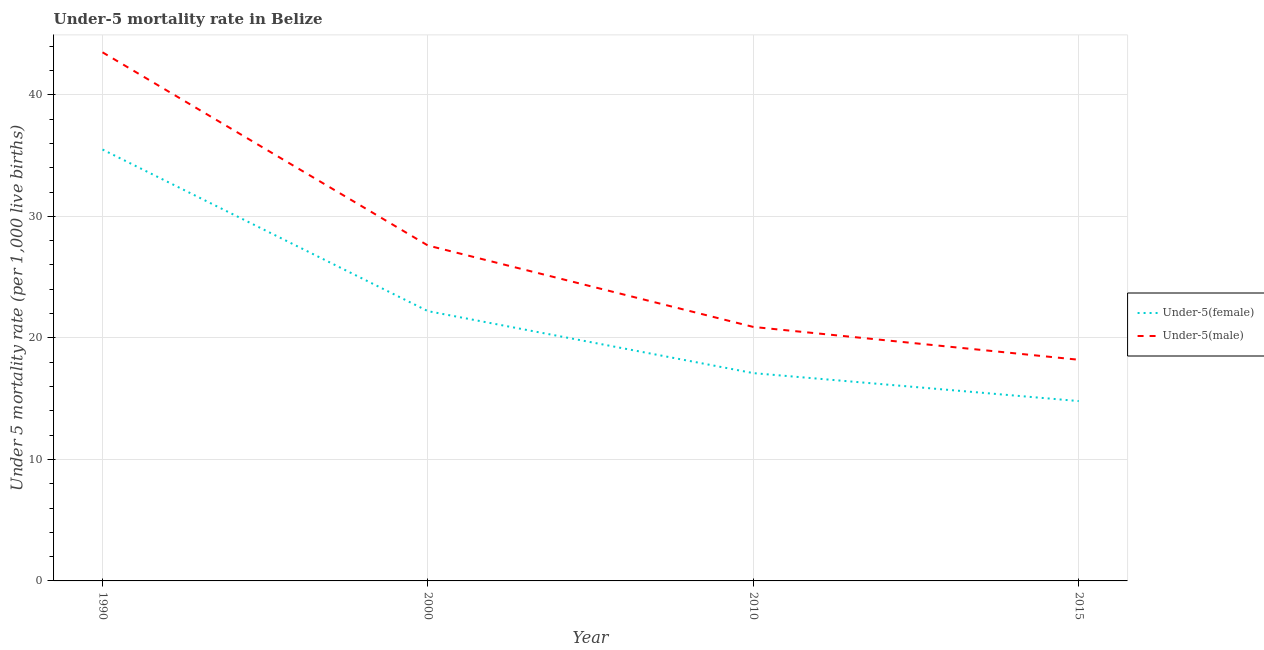How many different coloured lines are there?
Make the answer very short. 2. Does the line corresponding to under-5 female mortality rate intersect with the line corresponding to under-5 male mortality rate?
Offer a very short reply. No. What is the under-5 male mortality rate in 2000?
Make the answer very short. 27.6. Across all years, what is the maximum under-5 male mortality rate?
Give a very brief answer. 43.5. Across all years, what is the minimum under-5 male mortality rate?
Ensure brevity in your answer.  18.2. In which year was the under-5 female mortality rate maximum?
Offer a very short reply. 1990. In which year was the under-5 female mortality rate minimum?
Keep it short and to the point. 2015. What is the total under-5 male mortality rate in the graph?
Your response must be concise. 110.2. What is the difference between the under-5 male mortality rate in 1990 and that in 2010?
Provide a succinct answer. 22.6. What is the difference between the under-5 male mortality rate in 2015 and the under-5 female mortality rate in 2000?
Ensure brevity in your answer.  -4. What is the average under-5 female mortality rate per year?
Make the answer very short. 22.4. In the year 2000, what is the difference between the under-5 male mortality rate and under-5 female mortality rate?
Provide a succinct answer. 5.4. In how many years, is the under-5 female mortality rate greater than 34?
Your response must be concise. 1. What is the ratio of the under-5 male mortality rate in 2000 to that in 2010?
Your answer should be compact. 1.32. What is the difference between the highest and the second highest under-5 female mortality rate?
Provide a short and direct response. 13.3. What is the difference between the highest and the lowest under-5 male mortality rate?
Offer a terse response. 25.3. In how many years, is the under-5 female mortality rate greater than the average under-5 female mortality rate taken over all years?
Make the answer very short. 1. Does the under-5 female mortality rate monotonically increase over the years?
Offer a terse response. No. Is the under-5 male mortality rate strictly less than the under-5 female mortality rate over the years?
Provide a succinct answer. No. How many years are there in the graph?
Provide a succinct answer. 4. What is the difference between two consecutive major ticks on the Y-axis?
Offer a terse response. 10. Are the values on the major ticks of Y-axis written in scientific E-notation?
Keep it short and to the point. No. Does the graph contain any zero values?
Ensure brevity in your answer.  No. How many legend labels are there?
Keep it short and to the point. 2. How are the legend labels stacked?
Your answer should be compact. Vertical. What is the title of the graph?
Offer a very short reply. Under-5 mortality rate in Belize. What is the label or title of the X-axis?
Keep it short and to the point. Year. What is the label or title of the Y-axis?
Provide a short and direct response. Under 5 mortality rate (per 1,0 live births). What is the Under 5 mortality rate (per 1,000 live births) in Under-5(female) in 1990?
Make the answer very short. 35.5. What is the Under 5 mortality rate (per 1,000 live births) of Under-5(male) in 1990?
Make the answer very short. 43.5. What is the Under 5 mortality rate (per 1,000 live births) of Under-5(male) in 2000?
Provide a succinct answer. 27.6. What is the Under 5 mortality rate (per 1,000 live births) of Under-5(male) in 2010?
Make the answer very short. 20.9. What is the Under 5 mortality rate (per 1,000 live births) of Under-5(female) in 2015?
Your answer should be compact. 14.8. What is the Under 5 mortality rate (per 1,000 live births) in Under-5(male) in 2015?
Provide a short and direct response. 18.2. Across all years, what is the maximum Under 5 mortality rate (per 1,000 live births) of Under-5(female)?
Make the answer very short. 35.5. Across all years, what is the maximum Under 5 mortality rate (per 1,000 live births) in Under-5(male)?
Keep it short and to the point. 43.5. Across all years, what is the minimum Under 5 mortality rate (per 1,000 live births) in Under-5(female)?
Ensure brevity in your answer.  14.8. Across all years, what is the minimum Under 5 mortality rate (per 1,000 live births) in Under-5(male)?
Ensure brevity in your answer.  18.2. What is the total Under 5 mortality rate (per 1,000 live births) of Under-5(female) in the graph?
Your answer should be compact. 89.6. What is the total Under 5 mortality rate (per 1,000 live births) of Under-5(male) in the graph?
Keep it short and to the point. 110.2. What is the difference between the Under 5 mortality rate (per 1,000 live births) of Under-5(female) in 1990 and that in 2010?
Provide a succinct answer. 18.4. What is the difference between the Under 5 mortality rate (per 1,000 live births) of Under-5(male) in 1990 and that in 2010?
Keep it short and to the point. 22.6. What is the difference between the Under 5 mortality rate (per 1,000 live births) of Under-5(female) in 1990 and that in 2015?
Your answer should be compact. 20.7. What is the difference between the Under 5 mortality rate (per 1,000 live births) of Under-5(male) in 1990 and that in 2015?
Provide a succinct answer. 25.3. What is the difference between the Under 5 mortality rate (per 1,000 live births) of Under-5(female) in 2000 and that in 2010?
Make the answer very short. 5.1. What is the difference between the Under 5 mortality rate (per 1,000 live births) in Under-5(female) in 2000 and that in 2015?
Provide a short and direct response. 7.4. What is the difference between the Under 5 mortality rate (per 1,000 live births) of Under-5(female) in 1990 and the Under 5 mortality rate (per 1,000 live births) of Under-5(male) in 2000?
Keep it short and to the point. 7.9. What is the difference between the Under 5 mortality rate (per 1,000 live births) in Under-5(female) in 1990 and the Under 5 mortality rate (per 1,000 live births) in Under-5(male) in 2010?
Your answer should be compact. 14.6. What is the difference between the Under 5 mortality rate (per 1,000 live births) in Under-5(female) in 1990 and the Under 5 mortality rate (per 1,000 live births) in Under-5(male) in 2015?
Give a very brief answer. 17.3. What is the difference between the Under 5 mortality rate (per 1,000 live births) of Under-5(female) in 2010 and the Under 5 mortality rate (per 1,000 live births) of Under-5(male) in 2015?
Provide a short and direct response. -1.1. What is the average Under 5 mortality rate (per 1,000 live births) of Under-5(female) per year?
Provide a succinct answer. 22.4. What is the average Under 5 mortality rate (per 1,000 live births) in Under-5(male) per year?
Give a very brief answer. 27.55. In the year 2000, what is the difference between the Under 5 mortality rate (per 1,000 live births) of Under-5(female) and Under 5 mortality rate (per 1,000 live births) of Under-5(male)?
Your answer should be compact. -5.4. In the year 2010, what is the difference between the Under 5 mortality rate (per 1,000 live births) of Under-5(female) and Under 5 mortality rate (per 1,000 live births) of Under-5(male)?
Give a very brief answer. -3.8. In the year 2015, what is the difference between the Under 5 mortality rate (per 1,000 live births) of Under-5(female) and Under 5 mortality rate (per 1,000 live births) of Under-5(male)?
Provide a succinct answer. -3.4. What is the ratio of the Under 5 mortality rate (per 1,000 live births) in Under-5(female) in 1990 to that in 2000?
Your answer should be very brief. 1.6. What is the ratio of the Under 5 mortality rate (per 1,000 live births) of Under-5(male) in 1990 to that in 2000?
Make the answer very short. 1.58. What is the ratio of the Under 5 mortality rate (per 1,000 live births) of Under-5(female) in 1990 to that in 2010?
Keep it short and to the point. 2.08. What is the ratio of the Under 5 mortality rate (per 1,000 live births) of Under-5(male) in 1990 to that in 2010?
Give a very brief answer. 2.08. What is the ratio of the Under 5 mortality rate (per 1,000 live births) in Under-5(female) in 1990 to that in 2015?
Offer a terse response. 2.4. What is the ratio of the Under 5 mortality rate (per 1,000 live births) of Under-5(male) in 1990 to that in 2015?
Offer a terse response. 2.39. What is the ratio of the Under 5 mortality rate (per 1,000 live births) in Under-5(female) in 2000 to that in 2010?
Provide a short and direct response. 1.3. What is the ratio of the Under 5 mortality rate (per 1,000 live births) in Under-5(male) in 2000 to that in 2010?
Provide a succinct answer. 1.32. What is the ratio of the Under 5 mortality rate (per 1,000 live births) in Under-5(female) in 2000 to that in 2015?
Offer a terse response. 1.5. What is the ratio of the Under 5 mortality rate (per 1,000 live births) in Under-5(male) in 2000 to that in 2015?
Keep it short and to the point. 1.52. What is the ratio of the Under 5 mortality rate (per 1,000 live births) in Under-5(female) in 2010 to that in 2015?
Your response must be concise. 1.16. What is the ratio of the Under 5 mortality rate (per 1,000 live births) of Under-5(male) in 2010 to that in 2015?
Provide a short and direct response. 1.15. What is the difference between the highest and the second highest Under 5 mortality rate (per 1,000 live births) of Under-5(male)?
Provide a succinct answer. 15.9. What is the difference between the highest and the lowest Under 5 mortality rate (per 1,000 live births) in Under-5(female)?
Your answer should be very brief. 20.7. What is the difference between the highest and the lowest Under 5 mortality rate (per 1,000 live births) of Under-5(male)?
Ensure brevity in your answer.  25.3. 